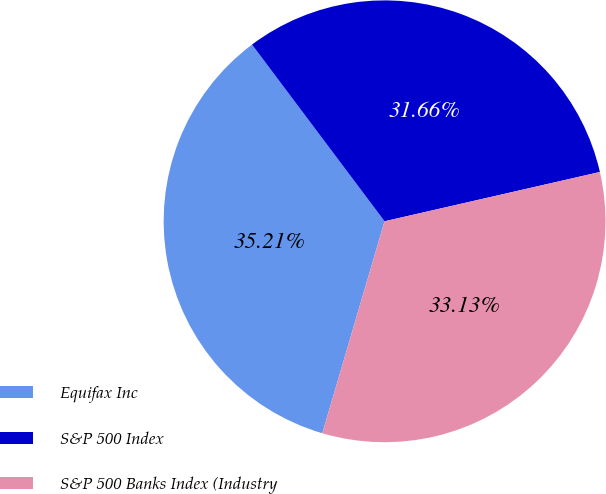<chart> <loc_0><loc_0><loc_500><loc_500><pie_chart><fcel>Equifax Inc<fcel>S&P 500 Index<fcel>S&P 500 Banks Index (Industry<nl><fcel>35.21%<fcel>31.66%<fcel>33.13%<nl></chart> 